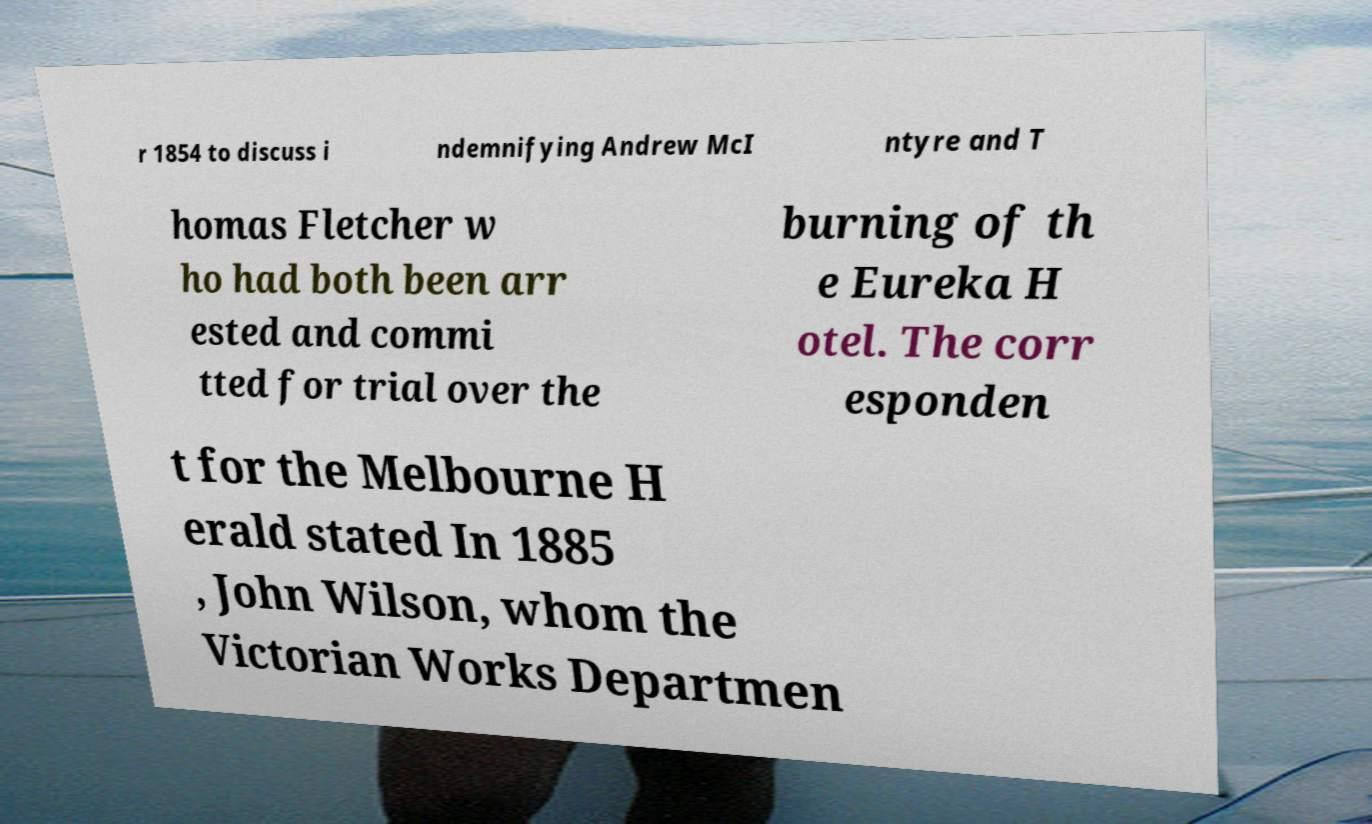Please read and relay the text visible in this image. What does it say? r 1854 to discuss i ndemnifying Andrew McI ntyre and T homas Fletcher w ho had both been arr ested and commi tted for trial over the burning of th e Eureka H otel. The corr esponden t for the Melbourne H erald stated In 1885 , John Wilson, whom the Victorian Works Departmen 